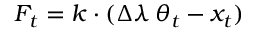<formula> <loc_0><loc_0><loc_500><loc_500>F _ { t } = k \cdot ( \Delta \lambda \, \theta _ { t } - x _ { t } )</formula> 